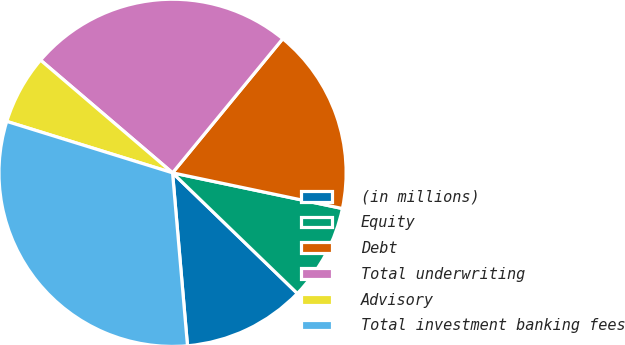<chart> <loc_0><loc_0><loc_500><loc_500><pie_chart><fcel>(in millions)<fcel>Equity<fcel>Debt<fcel>Total underwriting<fcel>Advisory<fcel>Total investment banking fees<nl><fcel>11.4%<fcel>8.93%<fcel>17.35%<fcel>24.7%<fcel>6.46%<fcel>31.16%<nl></chart> 